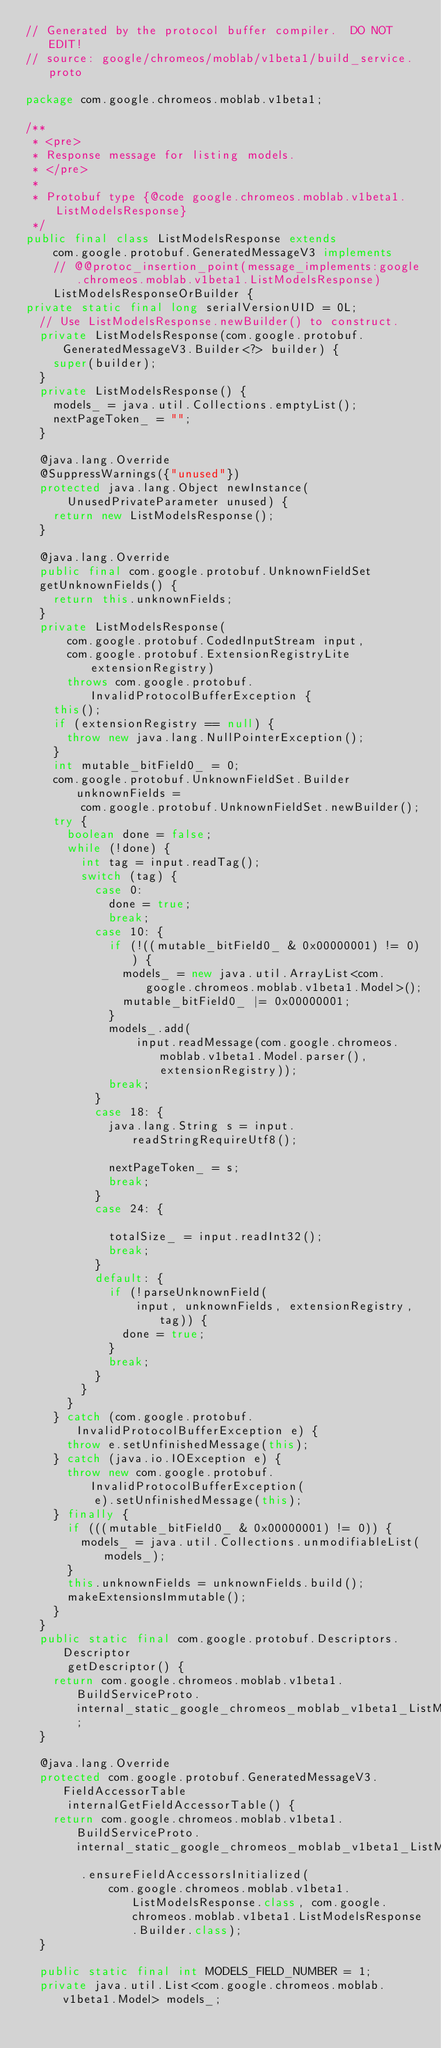Convert code to text. <code><loc_0><loc_0><loc_500><loc_500><_Java_>// Generated by the protocol buffer compiler.  DO NOT EDIT!
// source: google/chromeos/moblab/v1beta1/build_service.proto

package com.google.chromeos.moblab.v1beta1;

/**
 * <pre>
 * Response message for listing models.
 * </pre>
 *
 * Protobuf type {@code google.chromeos.moblab.v1beta1.ListModelsResponse}
 */
public final class ListModelsResponse extends
    com.google.protobuf.GeneratedMessageV3 implements
    // @@protoc_insertion_point(message_implements:google.chromeos.moblab.v1beta1.ListModelsResponse)
    ListModelsResponseOrBuilder {
private static final long serialVersionUID = 0L;
  // Use ListModelsResponse.newBuilder() to construct.
  private ListModelsResponse(com.google.protobuf.GeneratedMessageV3.Builder<?> builder) {
    super(builder);
  }
  private ListModelsResponse() {
    models_ = java.util.Collections.emptyList();
    nextPageToken_ = "";
  }

  @java.lang.Override
  @SuppressWarnings({"unused"})
  protected java.lang.Object newInstance(
      UnusedPrivateParameter unused) {
    return new ListModelsResponse();
  }

  @java.lang.Override
  public final com.google.protobuf.UnknownFieldSet
  getUnknownFields() {
    return this.unknownFields;
  }
  private ListModelsResponse(
      com.google.protobuf.CodedInputStream input,
      com.google.protobuf.ExtensionRegistryLite extensionRegistry)
      throws com.google.protobuf.InvalidProtocolBufferException {
    this();
    if (extensionRegistry == null) {
      throw new java.lang.NullPointerException();
    }
    int mutable_bitField0_ = 0;
    com.google.protobuf.UnknownFieldSet.Builder unknownFields =
        com.google.protobuf.UnknownFieldSet.newBuilder();
    try {
      boolean done = false;
      while (!done) {
        int tag = input.readTag();
        switch (tag) {
          case 0:
            done = true;
            break;
          case 10: {
            if (!((mutable_bitField0_ & 0x00000001) != 0)) {
              models_ = new java.util.ArrayList<com.google.chromeos.moblab.v1beta1.Model>();
              mutable_bitField0_ |= 0x00000001;
            }
            models_.add(
                input.readMessage(com.google.chromeos.moblab.v1beta1.Model.parser(), extensionRegistry));
            break;
          }
          case 18: {
            java.lang.String s = input.readStringRequireUtf8();

            nextPageToken_ = s;
            break;
          }
          case 24: {

            totalSize_ = input.readInt32();
            break;
          }
          default: {
            if (!parseUnknownField(
                input, unknownFields, extensionRegistry, tag)) {
              done = true;
            }
            break;
          }
        }
      }
    } catch (com.google.protobuf.InvalidProtocolBufferException e) {
      throw e.setUnfinishedMessage(this);
    } catch (java.io.IOException e) {
      throw new com.google.protobuf.InvalidProtocolBufferException(
          e).setUnfinishedMessage(this);
    } finally {
      if (((mutable_bitField0_ & 0x00000001) != 0)) {
        models_ = java.util.Collections.unmodifiableList(models_);
      }
      this.unknownFields = unknownFields.build();
      makeExtensionsImmutable();
    }
  }
  public static final com.google.protobuf.Descriptors.Descriptor
      getDescriptor() {
    return com.google.chromeos.moblab.v1beta1.BuildServiceProto.internal_static_google_chromeos_moblab_v1beta1_ListModelsResponse_descriptor;
  }

  @java.lang.Override
  protected com.google.protobuf.GeneratedMessageV3.FieldAccessorTable
      internalGetFieldAccessorTable() {
    return com.google.chromeos.moblab.v1beta1.BuildServiceProto.internal_static_google_chromeos_moblab_v1beta1_ListModelsResponse_fieldAccessorTable
        .ensureFieldAccessorsInitialized(
            com.google.chromeos.moblab.v1beta1.ListModelsResponse.class, com.google.chromeos.moblab.v1beta1.ListModelsResponse.Builder.class);
  }

  public static final int MODELS_FIELD_NUMBER = 1;
  private java.util.List<com.google.chromeos.moblab.v1beta1.Model> models_;</code> 